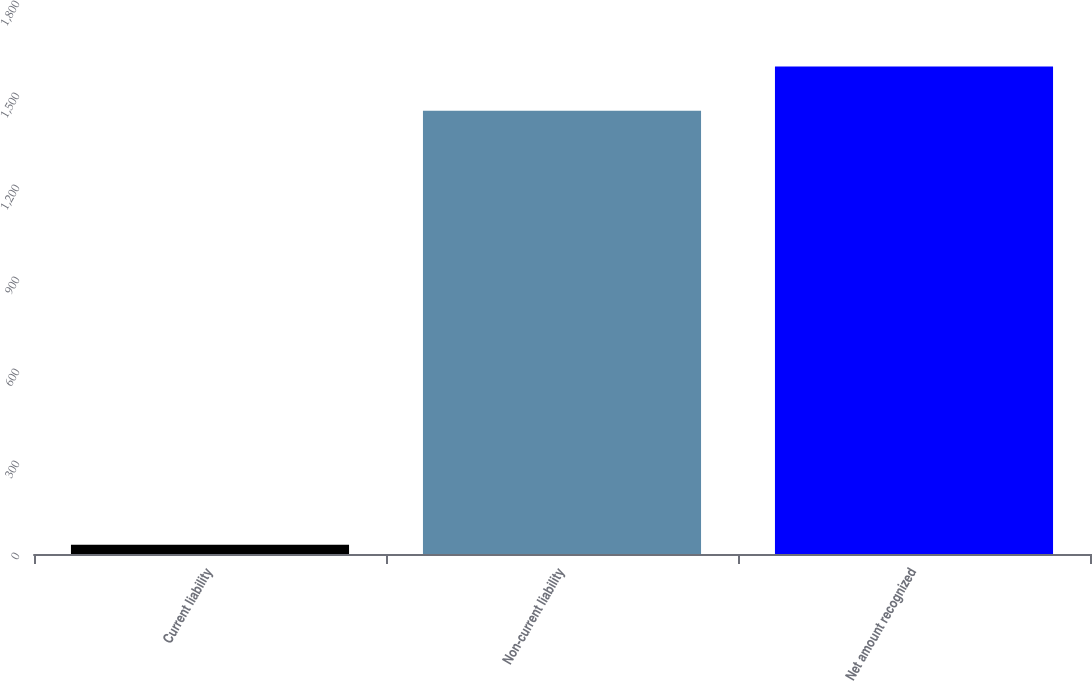Convert chart to OTSL. <chart><loc_0><loc_0><loc_500><loc_500><bar_chart><fcel>Current liability<fcel>Non-current liability<fcel>Net amount recognized<nl><fcel>30<fcel>1445<fcel>1589.5<nl></chart> 